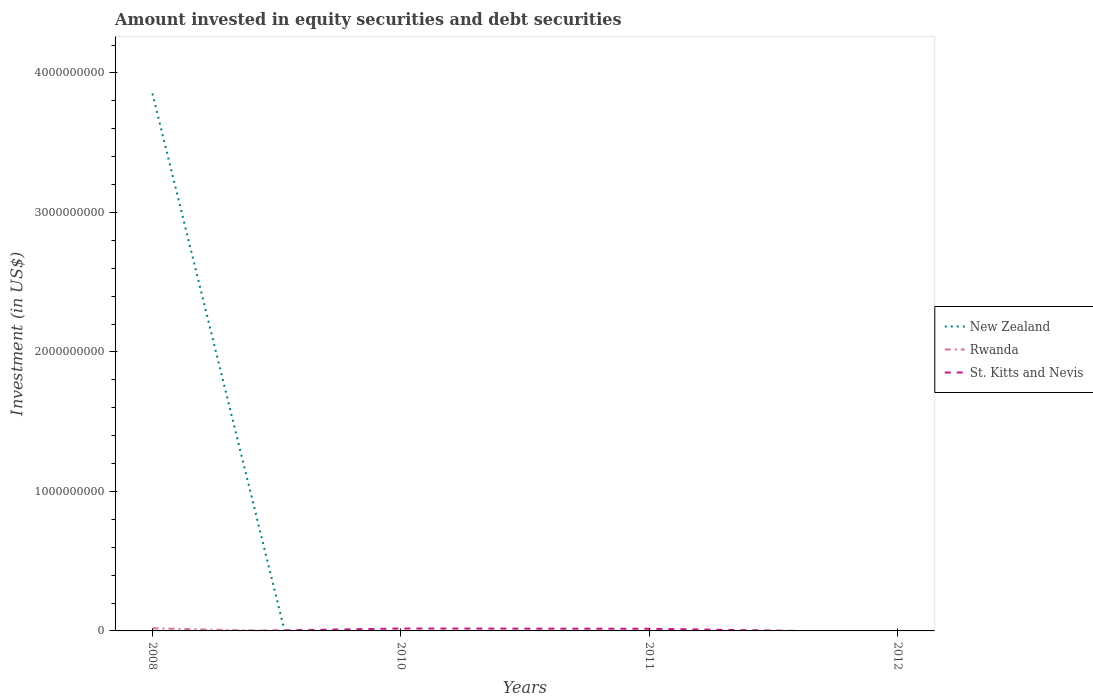Does the line corresponding to Rwanda intersect with the line corresponding to New Zealand?
Provide a short and direct response. Yes. Across all years, what is the maximum amount invested in equity securities and debt securities in St. Kitts and Nevis?
Your response must be concise. 0. What is the difference between the highest and the second highest amount invested in equity securities and debt securities in New Zealand?
Keep it short and to the point. 3.85e+09. What is the difference between the highest and the lowest amount invested in equity securities and debt securities in St. Kitts and Nevis?
Give a very brief answer. 2. How many lines are there?
Offer a very short reply. 3. How many years are there in the graph?
Offer a very short reply. 4. Are the values on the major ticks of Y-axis written in scientific E-notation?
Provide a short and direct response. No. Does the graph contain any zero values?
Make the answer very short. Yes. How many legend labels are there?
Provide a short and direct response. 3. What is the title of the graph?
Provide a short and direct response. Amount invested in equity securities and debt securities. Does "Somalia" appear as one of the legend labels in the graph?
Offer a very short reply. No. What is the label or title of the Y-axis?
Ensure brevity in your answer.  Investment (in US$). What is the Investment (in US$) of New Zealand in 2008?
Keep it short and to the point. 3.85e+09. What is the Investment (in US$) of Rwanda in 2008?
Provide a succinct answer. 1.88e+07. What is the Investment (in US$) in St. Kitts and Nevis in 2008?
Make the answer very short. 0. What is the Investment (in US$) in New Zealand in 2010?
Offer a very short reply. 0. What is the Investment (in US$) of Rwanda in 2010?
Provide a short and direct response. 0. What is the Investment (in US$) in St. Kitts and Nevis in 2010?
Your response must be concise. 1.72e+07. What is the Investment (in US$) in St. Kitts and Nevis in 2011?
Provide a short and direct response. 1.55e+07. What is the Investment (in US$) of New Zealand in 2012?
Ensure brevity in your answer.  0. What is the Investment (in US$) in Rwanda in 2012?
Provide a succinct answer. 0. Across all years, what is the maximum Investment (in US$) in New Zealand?
Your answer should be very brief. 3.85e+09. Across all years, what is the maximum Investment (in US$) of Rwanda?
Provide a short and direct response. 1.88e+07. Across all years, what is the maximum Investment (in US$) in St. Kitts and Nevis?
Keep it short and to the point. 1.72e+07. Across all years, what is the minimum Investment (in US$) in New Zealand?
Give a very brief answer. 0. Across all years, what is the minimum Investment (in US$) of St. Kitts and Nevis?
Provide a short and direct response. 0. What is the total Investment (in US$) in New Zealand in the graph?
Offer a very short reply. 3.85e+09. What is the total Investment (in US$) of Rwanda in the graph?
Provide a short and direct response. 1.88e+07. What is the total Investment (in US$) of St. Kitts and Nevis in the graph?
Make the answer very short. 3.27e+07. What is the difference between the Investment (in US$) of St. Kitts and Nevis in 2010 and that in 2011?
Your answer should be compact. 1.78e+06. What is the difference between the Investment (in US$) in New Zealand in 2008 and the Investment (in US$) in St. Kitts and Nevis in 2010?
Your answer should be compact. 3.84e+09. What is the difference between the Investment (in US$) in Rwanda in 2008 and the Investment (in US$) in St. Kitts and Nevis in 2010?
Offer a terse response. 1.55e+06. What is the difference between the Investment (in US$) of New Zealand in 2008 and the Investment (in US$) of St. Kitts and Nevis in 2011?
Your answer should be very brief. 3.84e+09. What is the difference between the Investment (in US$) in Rwanda in 2008 and the Investment (in US$) in St. Kitts and Nevis in 2011?
Provide a succinct answer. 3.33e+06. What is the average Investment (in US$) of New Zealand per year?
Keep it short and to the point. 9.63e+08. What is the average Investment (in US$) of Rwanda per year?
Provide a short and direct response. 4.70e+06. What is the average Investment (in US$) of St. Kitts and Nevis per year?
Your answer should be compact. 8.18e+06. In the year 2008, what is the difference between the Investment (in US$) in New Zealand and Investment (in US$) in Rwanda?
Give a very brief answer. 3.83e+09. What is the ratio of the Investment (in US$) of St. Kitts and Nevis in 2010 to that in 2011?
Make the answer very short. 1.12. What is the difference between the highest and the lowest Investment (in US$) of New Zealand?
Offer a very short reply. 3.85e+09. What is the difference between the highest and the lowest Investment (in US$) in Rwanda?
Keep it short and to the point. 1.88e+07. What is the difference between the highest and the lowest Investment (in US$) of St. Kitts and Nevis?
Provide a succinct answer. 1.72e+07. 